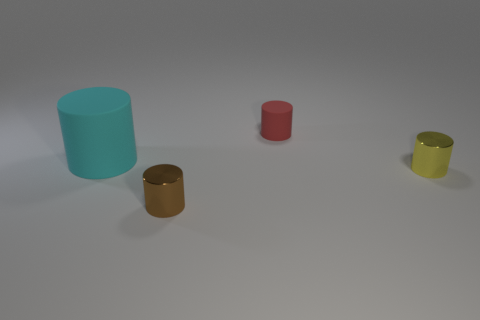Add 1 big cyan things. How many objects exist? 5 Add 2 shiny cylinders. How many shiny cylinders exist? 4 Subtract 0 brown spheres. How many objects are left? 4 Subtract all big blue rubber spheres. Subtract all yellow objects. How many objects are left? 3 Add 1 small brown cylinders. How many small brown cylinders are left? 2 